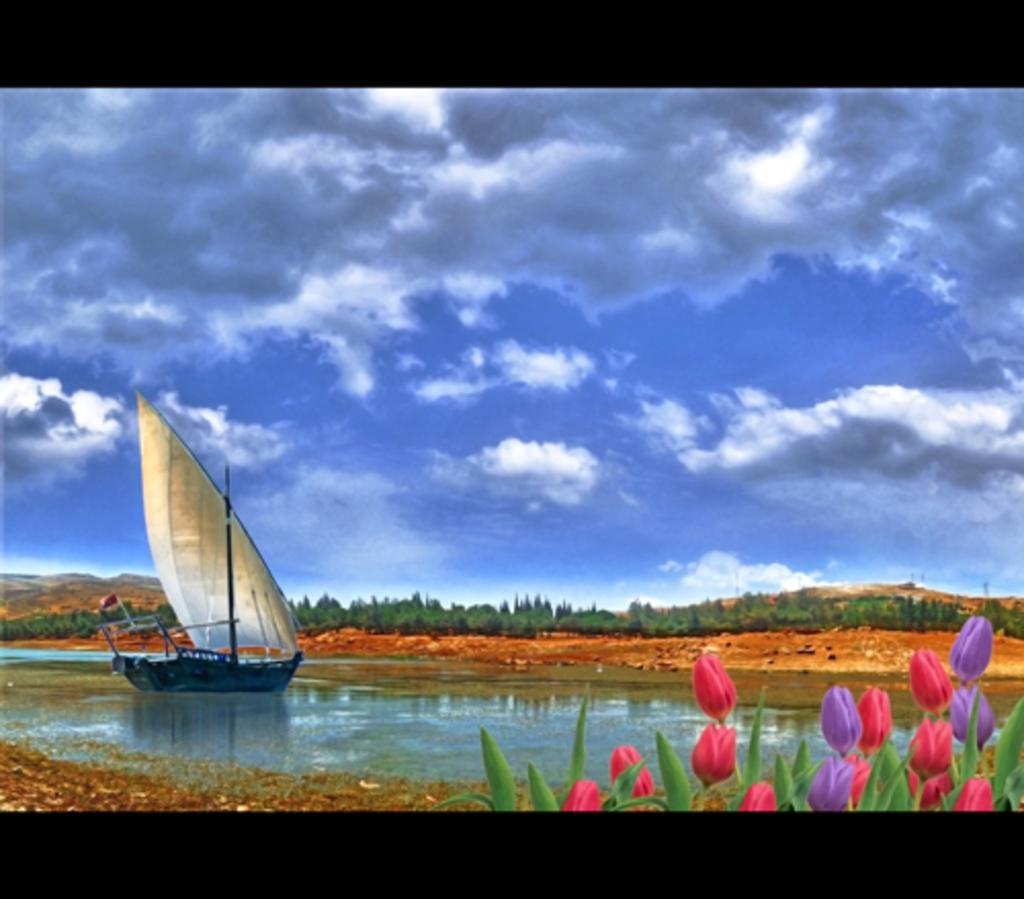In one or two sentences, can you explain what this image depicts? In the image we can see there is a poster in which there are flowers on the plants and there is water on the ground. There is sail boat on the water and behind there are lot of trees. There is a clear sky. 